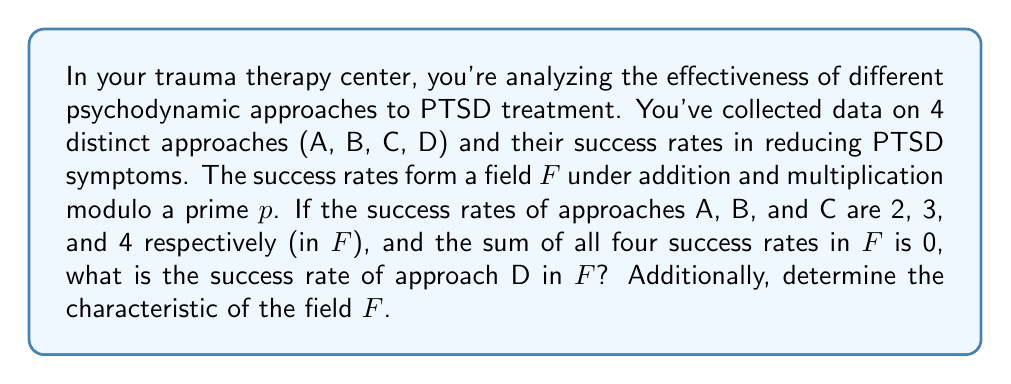Solve this math problem. Let's approach this step-by-step:

1) We're given that the success rates form a field $F$ under addition and multiplication modulo some prime $p$. Let's denote the success rate of approach D as $x$.

2) We know that in $F$:
   $A = 2$, $B = 3$, $C = 4$, and $D = x$

3) We're told that the sum of all four success rates in $F$ is 0. In field theory, this means:

   $$(2 + 3 + 4 + x) \equiv 0 \pmod{p}$$

4) Simplifying:

   $$(9 + x) \equiv 0 \pmod{p}$$

5) In a field, every element has an additive inverse. So, we can add the additive inverse of 9 to both sides:

   $$x \equiv -9 \pmod{p}$$

6) In modular arithmetic, $-9$ is equivalent to $p-9$. So, $x = p-9$ in $F$.

7) Now, we need to determine $p$. We know that 2, 3, and 4 are distinct elements in $F$, so $p$ must be greater than 4. The smallest such prime that makes $x$ distinct from 2, 3, and 4 is 13.

8) With $p = 13$, we have $x \equiv 13-9 \equiv 4 \pmod{13}$

9) However, we already have $C = 4$, so we need the next prime that works, which is 17.

10) With $p = 17$, we have $x \equiv 17-9 \equiv 8 \pmod{17}$

11) The characteristic of a field is the smallest positive integer $n$ such that $n \cdot 1 = 0$ in the field. In a finite field of prime order $p$, the characteristic is always $p$.
Answer: The success rate of approach D in $F$ is 8, and the characteristic of the field $F$ is 17. 